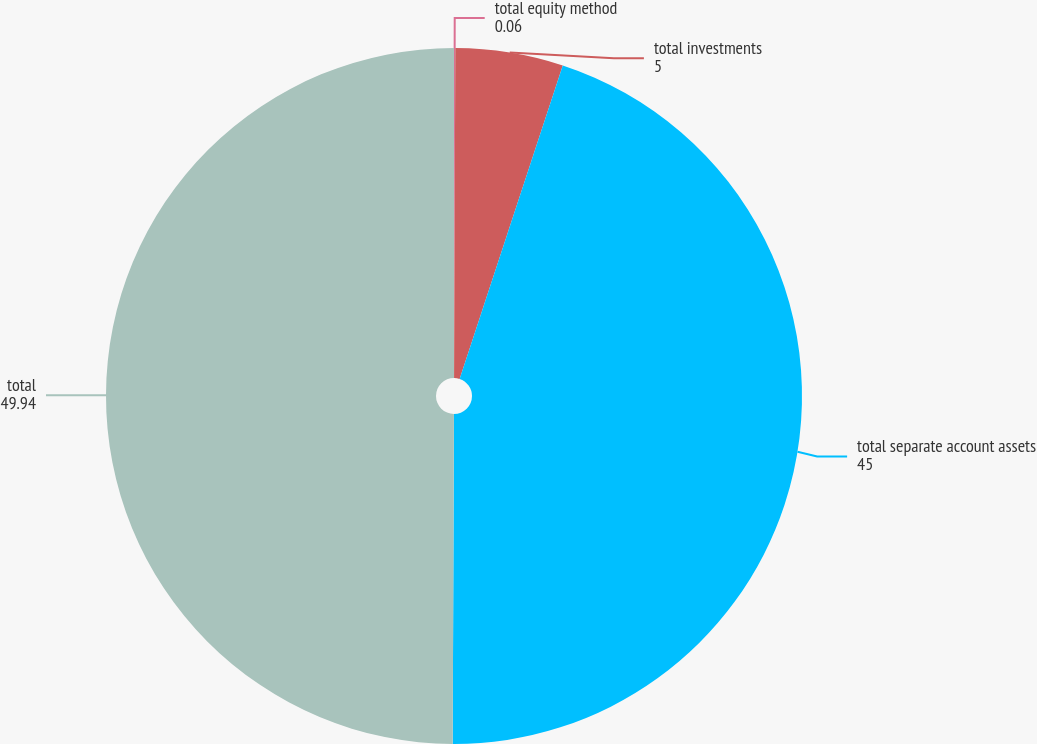Convert chart to OTSL. <chart><loc_0><loc_0><loc_500><loc_500><pie_chart><fcel>total equity method<fcel>total investments<fcel>total separate account assets<fcel>total<nl><fcel>0.06%<fcel>5.0%<fcel>45.0%<fcel>49.94%<nl></chart> 